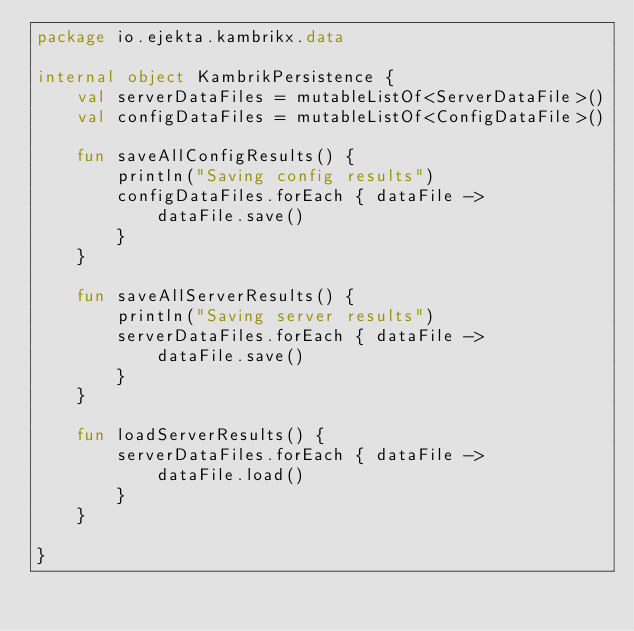<code> <loc_0><loc_0><loc_500><loc_500><_Kotlin_>package io.ejekta.kambrikx.data

internal object KambrikPersistence {
    val serverDataFiles = mutableListOf<ServerDataFile>()
    val configDataFiles = mutableListOf<ConfigDataFile>()

    fun saveAllConfigResults() {
        println("Saving config results")
        configDataFiles.forEach { dataFile ->
            dataFile.save()
        }
    }

    fun saveAllServerResults() {
        println("Saving server results")
        serverDataFiles.forEach { dataFile ->
            dataFile.save()
        }
    }

    fun loadServerResults() {
        serverDataFiles.forEach { dataFile ->
            dataFile.load()
        }
    }

}</code> 